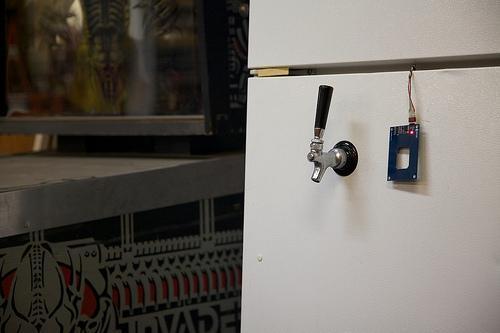How many colors in pattern?
Give a very brief answer. 3. 